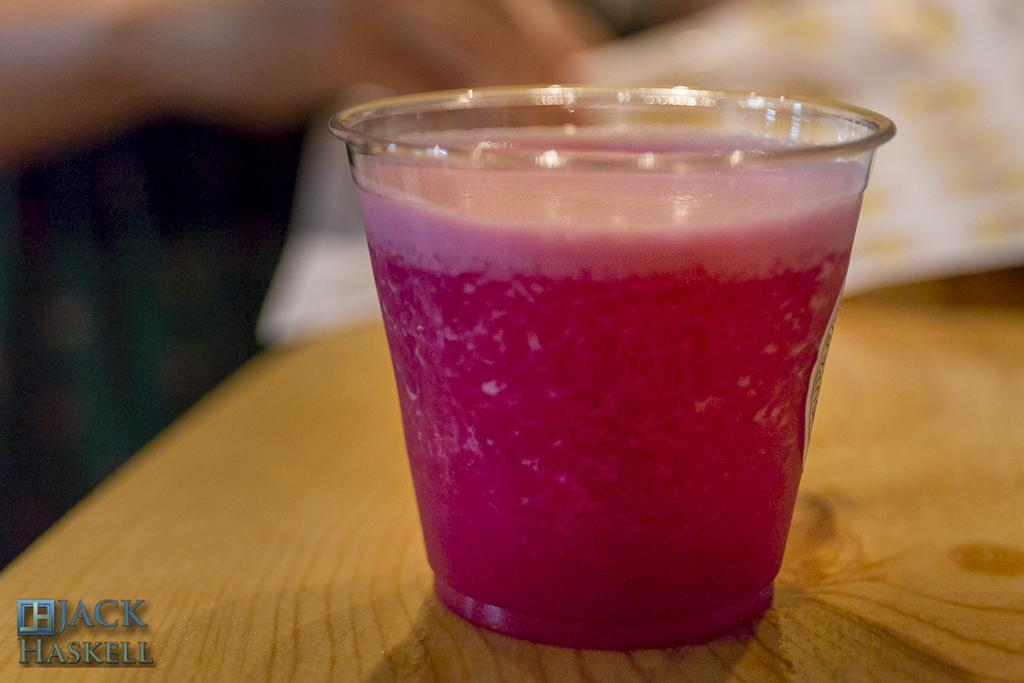What is the main object in the center of the image? There is a table in the center of the image. What can be seen on top of the table? There is a white color object on the table. What else is on the table besides the white object? There is a glass on the table. What is inside the glass? The glass contains pink color juice. Can you see a bone on the table in the image? No, there is no bone present on the table in the image. 